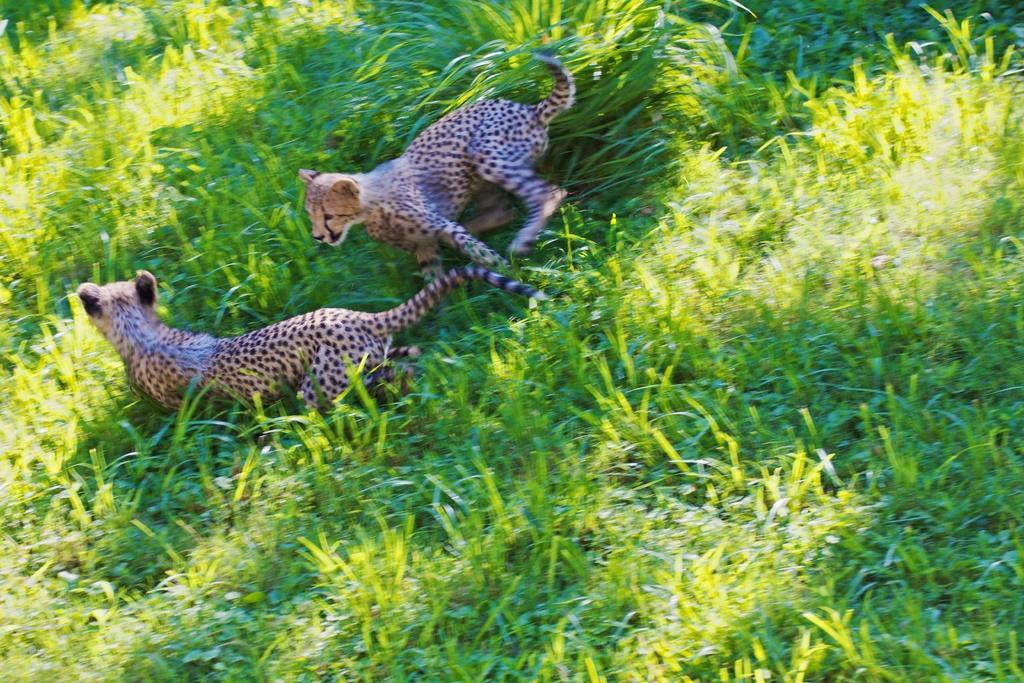In one or two sentences, can you explain what this image depicts? In this picture we can see couple of leopards and grass. 